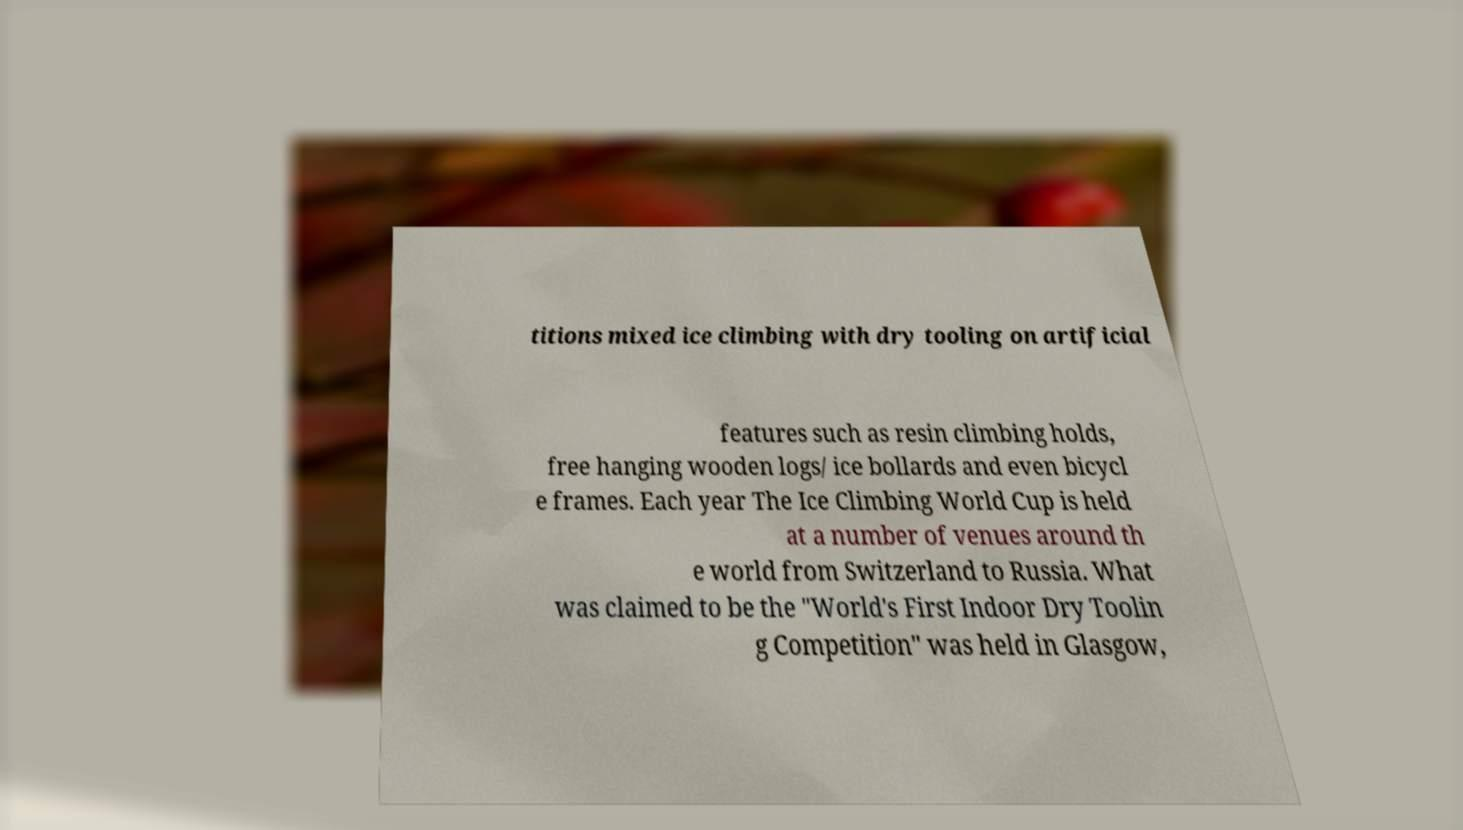Could you extract and type out the text from this image? titions mixed ice climbing with dry tooling on artificial features such as resin climbing holds, free hanging wooden logs/ ice bollards and even bicycl e frames. Each year The Ice Climbing World Cup is held at a number of venues around th e world from Switzerland to Russia. What was claimed to be the "World's First Indoor Dry Toolin g Competition" was held in Glasgow, 